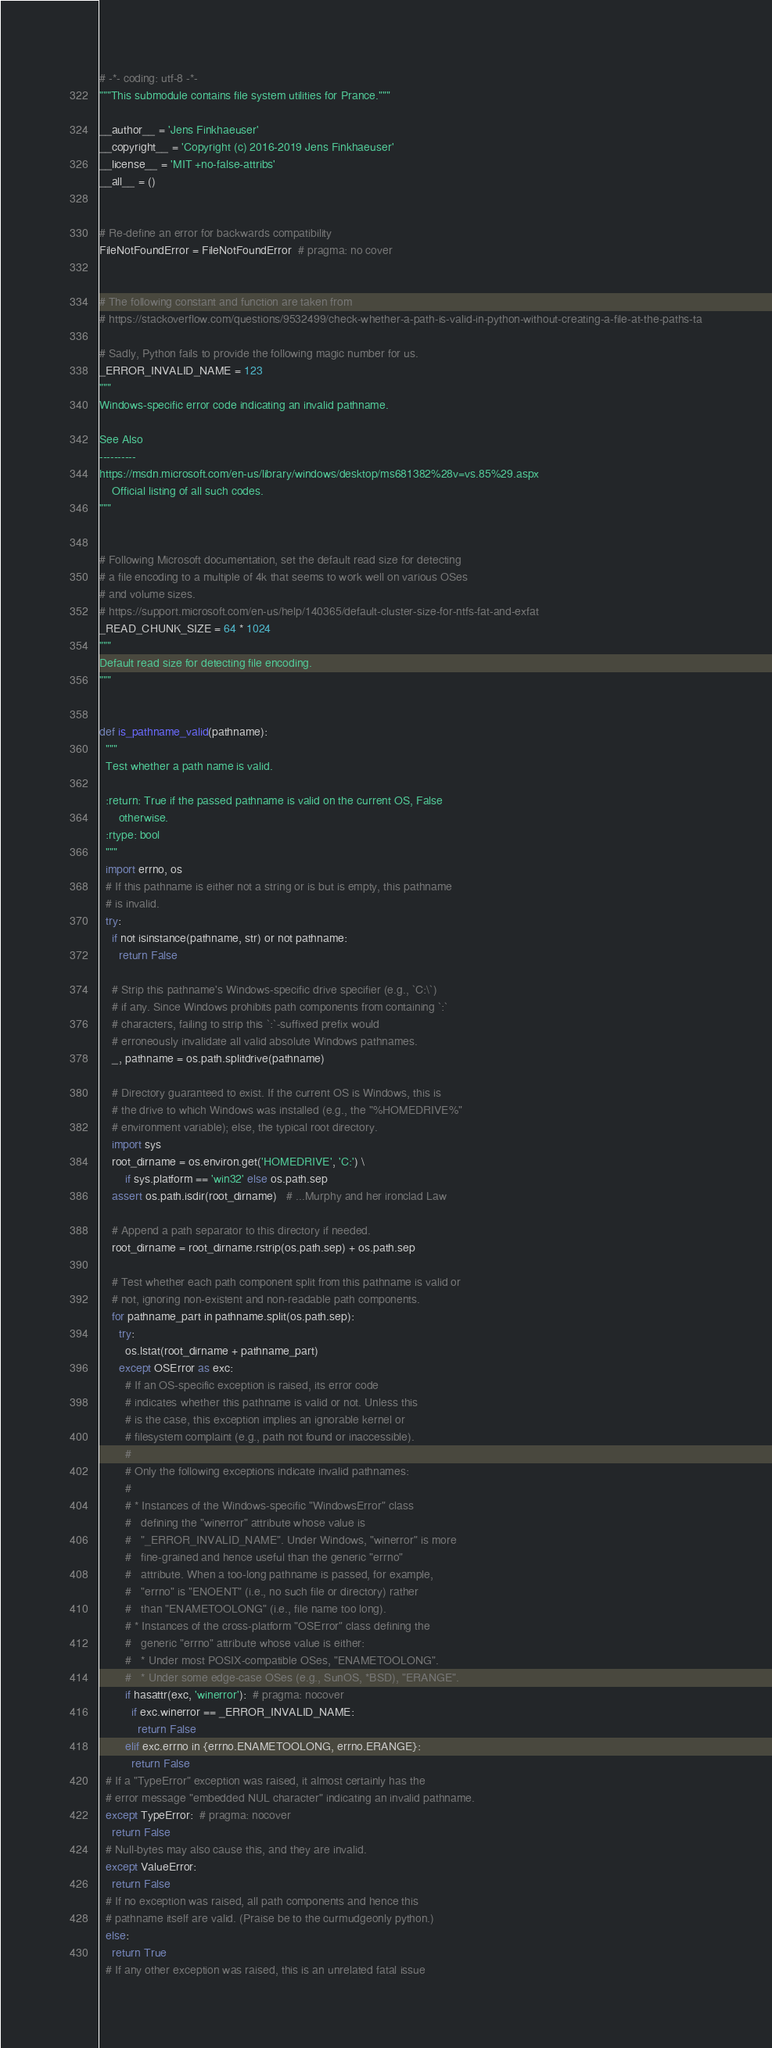<code> <loc_0><loc_0><loc_500><loc_500><_Python_># -*- coding: utf-8 -*-
"""This submodule contains file system utilities for Prance."""

__author__ = 'Jens Finkhaeuser'
__copyright__ = 'Copyright (c) 2016-2019 Jens Finkhaeuser'
__license__ = 'MIT +no-false-attribs'
__all__ = ()


# Re-define an error for backwards compatibility
FileNotFoundError = FileNotFoundError  # pragma: no cover


# The following constant and function are taken from
# https://stackoverflow.com/questions/9532499/check-whether-a-path-is-valid-in-python-without-creating-a-file-at-the-paths-ta

# Sadly, Python fails to provide the following magic number for us.
_ERROR_INVALID_NAME = 123
"""
Windows-specific error code indicating an invalid pathname.

See Also
----------
https://msdn.microsoft.com/en-us/library/windows/desktop/ms681382%28v=vs.85%29.aspx
    Official listing of all such codes.
"""


# Following Microsoft documentation, set the default read size for detecting
# a file encoding to a multiple of 4k that seems to work well on various OSes
# and volume sizes.
# https://support.microsoft.com/en-us/help/140365/default-cluster-size-for-ntfs-fat-and-exfat
_READ_CHUNK_SIZE = 64 * 1024
"""
Default read size for detecting file encoding.
"""


def is_pathname_valid(pathname):
  """
  Test whether a path name is valid.

  :return: True if the passed pathname is valid on the current OS, False
      otherwise.
  :rtype: bool
  """
  import errno, os
  # If this pathname is either not a string or is but is empty, this pathname
  # is invalid.
  try:
    if not isinstance(pathname, str) or not pathname:
      return False

    # Strip this pathname's Windows-specific drive specifier (e.g., `C:\`)
    # if any. Since Windows prohibits path components from containing `:`
    # characters, failing to strip this `:`-suffixed prefix would
    # erroneously invalidate all valid absolute Windows pathnames.
    _, pathname = os.path.splitdrive(pathname)

    # Directory guaranteed to exist. If the current OS is Windows, this is
    # the drive to which Windows was installed (e.g., the "%HOMEDRIVE%"
    # environment variable); else, the typical root directory.
    import sys
    root_dirname = os.environ.get('HOMEDRIVE', 'C:') \
        if sys.platform == 'win32' else os.path.sep
    assert os.path.isdir(root_dirname)   # ...Murphy and her ironclad Law

    # Append a path separator to this directory if needed.
    root_dirname = root_dirname.rstrip(os.path.sep) + os.path.sep

    # Test whether each path component split from this pathname is valid or
    # not, ignoring non-existent and non-readable path components.
    for pathname_part in pathname.split(os.path.sep):
      try:
        os.lstat(root_dirname + pathname_part)
      except OSError as exc:
        # If an OS-specific exception is raised, its error code
        # indicates whether this pathname is valid or not. Unless this
        # is the case, this exception implies an ignorable kernel or
        # filesystem complaint (e.g., path not found or inaccessible).
        #
        # Only the following exceptions indicate invalid pathnames:
        #
        # * Instances of the Windows-specific "WindowsError" class
        #   defining the "winerror" attribute whose value is
        #   "_ERROR_INVALID_NAME". Under Windows, "winerror" is more
        #   fine-grained and hence useful than the generic "errno"
        #   attribute. When a too-long pathname is passed, for example,
        #   "errno" is "ENOENT" (i.e., no such file or directory) rather
        #   than "ENAMETOOLONG" (i.e., file name too long).
        # * Instances of the cross-platform "OSError" class defining the
        #   generic "errno" attribute whose value is either:
        #   * Under most POSIX-compatible OSes, "ENAMETOOLONG".
        #   * Under some edge-case OSes (e.g., SunOS, *BSD), "ERANGE".
        if hasattr(exc, 'winerror'):  # pragma: nocover
          if exc.winerror == _ERROR_INVALID_NAME:
            return False
        elif exc.errno in {errno.ENAMETOOLONG, errno.ERANGE}:
          return False
  # If a "TypeError" exception was raised, it almost certainly has the
  # error message "embedded NUL character" indicating an invalid pathname.
  except TypeError:  # pragma: nocover
    return False
  # Null-bytes may also cause this, and they are invalid.
  except ValueError:
    return False
  # If no exception was raised, all path components and hence this
  # pathname itself are valid. (Praise be to the curmudgeonly python.)
  else:
    return True
  # If any other exception was raised, this is an unrelated fatal issue</code> 